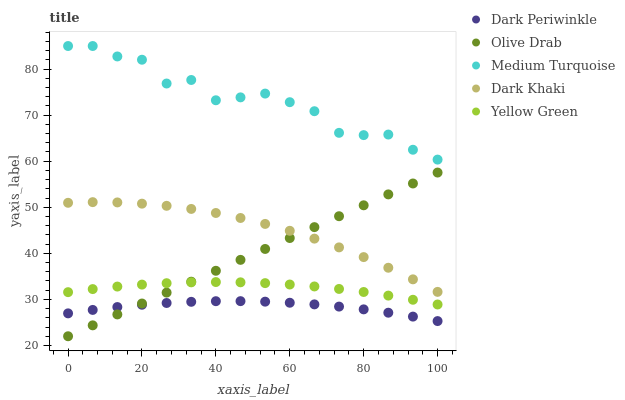Does Dark Periwinkle have the minimum area under the curve?
Answer yes or no. Yes. Does Medium Turquoise have the maximum area under the curve?
Answer yes or no. Yes. Does Medium Turquoise have the minimum area under the curve?
Answer yes or no. No. Does Dark Periwinkle have the maximum area under the curve?
Answer yes or no. No. Is Olive Drab the smoothest?
Answer yes or no. Yes. Is Medium Turquoise the roughest?
Answer yes or no. Yes. Is Dark Periwinkle the smoothest?
Answer yes or no. No. Is Dark Periwinkle the roughest?
Answer yes or no. No. Does Olive Drab have the lowest value?
Answer yes or no. Yes. Does Dark Periwinkle have the lowest value?
Answer yes or no. No. Does Medium Turquoise have the highest value?
Answer yes or no. Yes. Does Dark Periwinkle have the highest value?
Answer yes or no. No. Is Dark Periwinkle less than Yellow Green?
Answer yes or no. Yes. Is Dark Khaki greater than Yellow Green?
Answer yes or no. Yes. Does Olive Drab intersect Dark Khaki?
Answer yes or no. Yes. Is Olive Drab less than Dark Khaki?
Answer yes or no. No. Is Olive Drab greater than Dark Khaki?
Answer yes or no. No. Does Dark Periwinkle intersect Yellow Green?
Answer yes or no. No. 